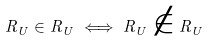<formula> <loc_0><loc_0><loc_500><loc_500>R _ { U } \in R _ { U } \iff R _ { U } \notin R _ { U }</formula> 